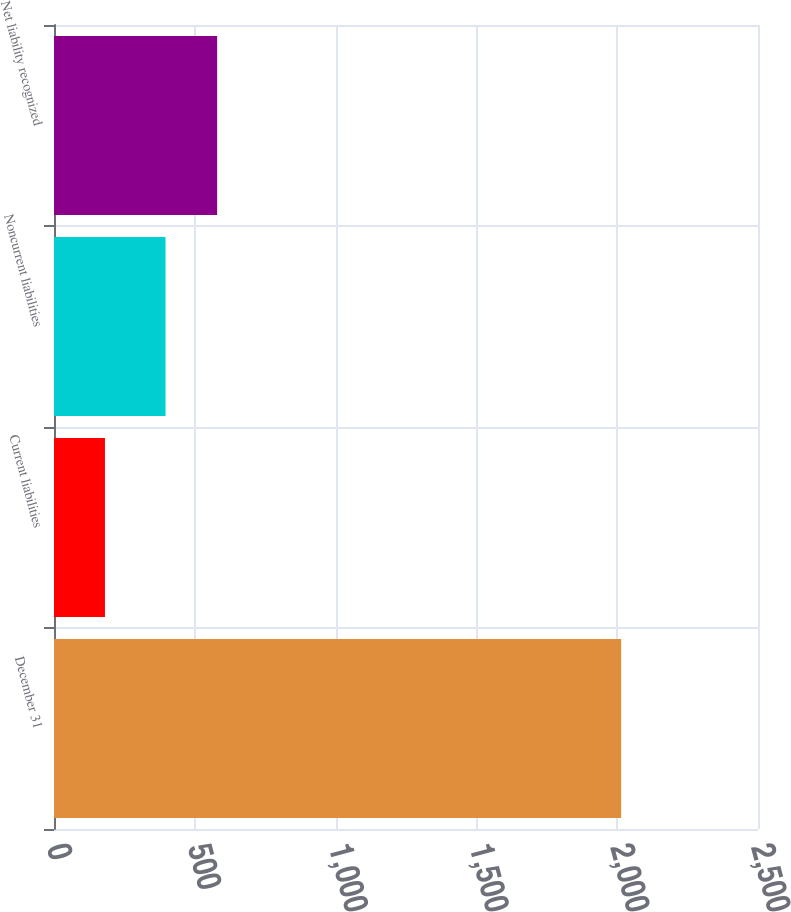<chart> <loc_0><loc_0><loc_500><loc_500><bar_chart><fcel>December 31<fcel>Current liabilities<fcel>Noncurrent liabilities<fcel>Net liability recognized<nl><fcel>2014<fcel>181<fcel>396<fcel>579.3<nl></chart> 